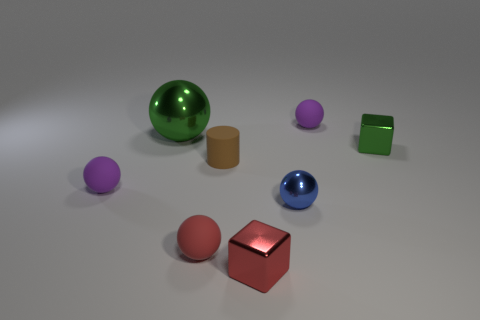The other object that is the same color as the big metal thing is what size?
Provide a succinct answer. Small. What is the size of the green metal object that is the same shape as the tiny red metal object?
Your answer should be compact. Small. There is a tiny purple sphere left of the tiny cube in front of the blue thing; what number of tiny metal things are in front of it?
Provide a short and direct response. 2. Are there an equal number of big green metallic spheres that are in front of the tiny blue ball and big brown blocks?
Offer a terse response. Yes. What number of cubes are tiny blue metal objects or tiny metal things?
Your answer should be compact. 2. Is the rubber cylinder the same color as the big object?
Ensure brevity in your answer.  No. Are there the same number of brown cylinders that are right of the tiny green shiny object and large green objects behind the tiny blue ball?
Ensure brevity in your answer.  No. What color is the cylinder?
Offer a terse response. Brown. How many things are either purple matte objects that are left of the big green shiny ball or large green shiny things?
Your answer should be very brief. 2. There is a purple object that is behind the tiny green shiny object; is it the same size as the purple rubber ball in front of the tiny green metal block?
Offer a terse response. Yes. 